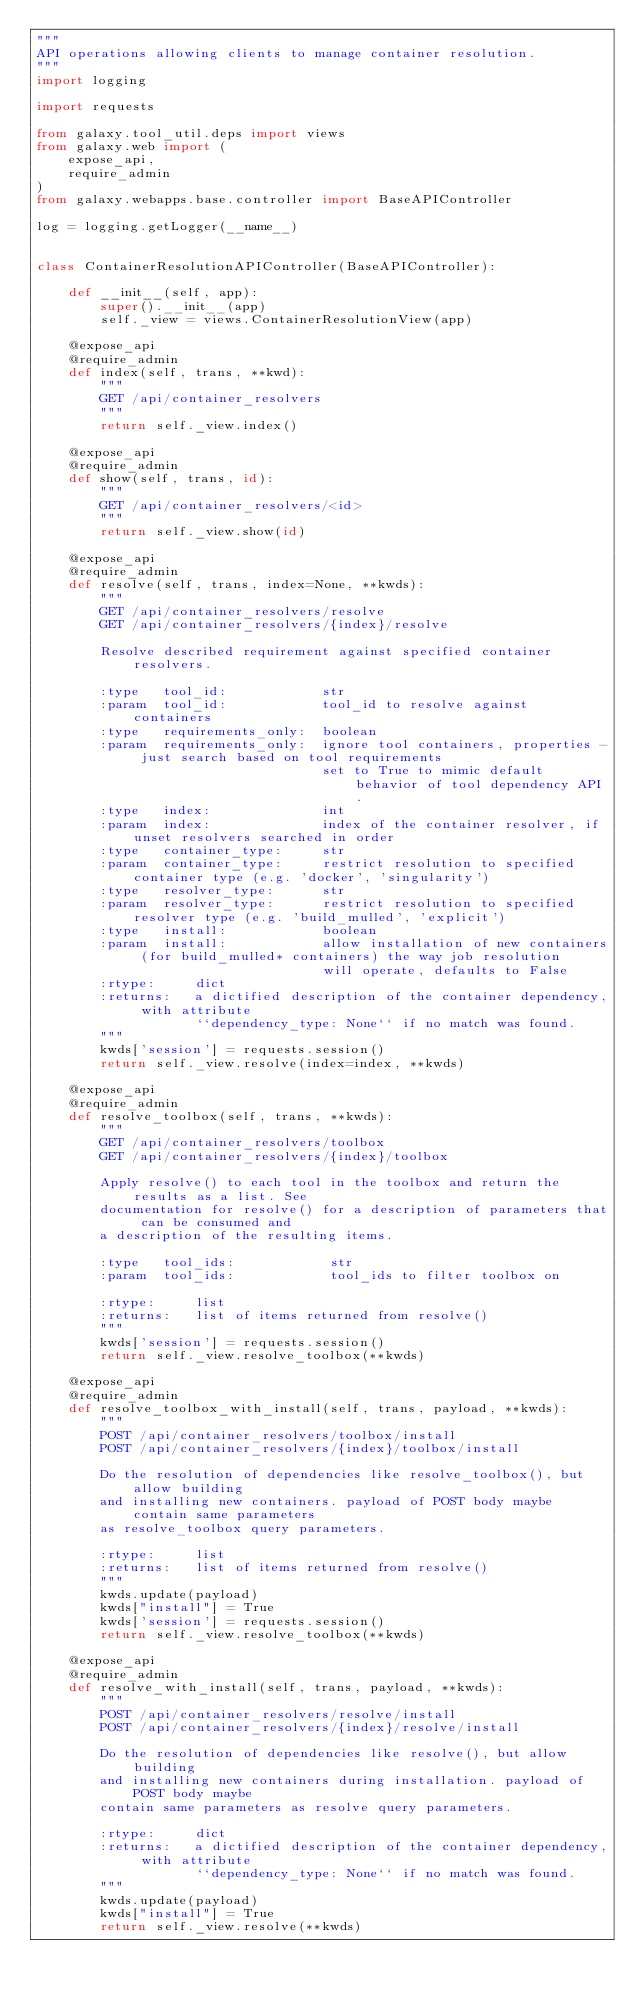Convert code to text. <code><loc_0><loc_0><loc_500><loc_500><_Python_>"""
API operations allowing clients to manage container resolution.
"""
import logging

import requests

from galaxy.tool_util.deps import views
from galaxy.web import (
    expose_api,
    require_admin
)
from galaxy.webapps.base.controller import BaseAPIController

log = logging.getLogger(__name__)


class ContainerResolutionAPIController(BaseAPIController):

    def __init__(self, app):
        super().__init__(app)
        self._view = views.ContainerResolutionView(app)

    @expose_api
    @require_admin
    def index(self, trans, **kwd):
        """
        GET /api/container_resolvers
        """
        return self._view.index()

    @expose_api
    @require_admin
    def show(self, trans, id):
        """
        GET /api/container_resolvers/<id>
        """
        return self._view.show(id)

    @expose_api
    @require_admin
    def resolve(self, trans, index=None, **kwds):
        """
        GET /api/container_resolvers/resolve
        GET /api/container_resolvers/{index}/resolve

        Resolve described requirement against specified container resolvers.

        :type   tool_id:            str
        :param  tool_id:            tool_id to resolve against containers
        :type   requirements_only:  boolean
        :param  requirements_only:  ignore tool containers, properties - just search based on tool requirements
                                    set to True to mimic default behavior of tool dependency API.
        :type   index:              int
        :param  index:              index of the container resolver, if unset resolvers searched in order
        :type   container_type:     str
        :param  container_type:     restrict resolution to specified container type (e.g. 'docker', 'singularity')
        :type   resolver_type:      str
        :param  resolver_type:      restrict resolution to specified resolver type (e.g. 'build_mulled', 'explicit')
        :type   install:            boolean
        :param  install:            allow installation of new containers (for build_mulled* containers) the way job resolution
                                    will operate, defaults to False
        :rtype:     dict
        :returns:   a dictified description of the container dependency, with attribute
                    ``dependency_type: None`` if no match was found.
        """
        kwds['session'] = requests.session()
        return self._view.resolve(index=index, **kwds)

    @expose_api
    @require_admin
    def resolve_toolbox(self, trans, **kwds):
        """
        GET /api/container_resolvers/toolbox
        GET /api/container_resolvers/{index}/toolbox

        Apply resolve() to each tool in the toolbox and return the results as a list. See
        documentation for resolve() for a description of parameters that can be consumed and
        a description of the resulting items.

        :type   tool_ids:            str
        :param  tool_ids:            tool_ids to filter toolbox on

        :rtype:     list
        :returns:   list of items returned from resolve()
        """
        kwds['session'] = requests.session()
        return self._view.resolve_toolbox(**kwds)

    @expose_api
    @require_admin
    def resolve_toolbox_with_install(self, trans, payload, **kwds):
        """
        POST /api/container_resolvers/toolbox/install
        POST /api/container_resolvers/{index}/toolbox/install

        Do the resolution of dependencies like resolve_toolbox(), but allow building
        and installing new containers. payload of POST body maybe contain same parameters
        as resolve_toolbox query parameters.

        :rtype:     list
        :returns:   list of items returned from resolve()
        """
        kwds.update(payload)
        kwds["install"] = True
        kwds['session'] = requests.session()
        return self._view.resolve_toolbox(**kwds)

    @expose_api
    @require_admin
    def resolve_with_install(self, trans, payload, **kwds):
        """
        POST /api/container_resolvers/resolve/install
        POST /api/container_resolvers/{index}/resolve/install

        Do the resolution of dependencies like resolve(), but allow building
        and installing new containers during installation. payload of POST body maybe
        contain same parameters as resolve query parameters.

        :rtype:     dict
        :returns:   a dictified description of the container dependency, with attribute
                    ``dependency_type: None`` if no match was found.
        """
        kwds.update(payload)
        kwds["install"] = True
        return self._view.resolve(**kwds)
</code> 